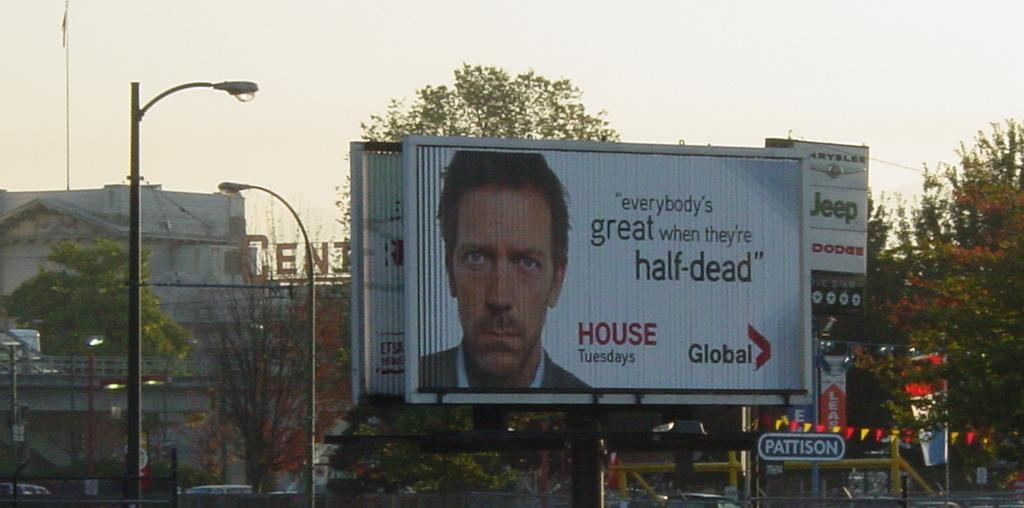<image>
Give a short and clear explanation of the subsequent image. a billboard that says 'everybody's great when they're half-dead' 